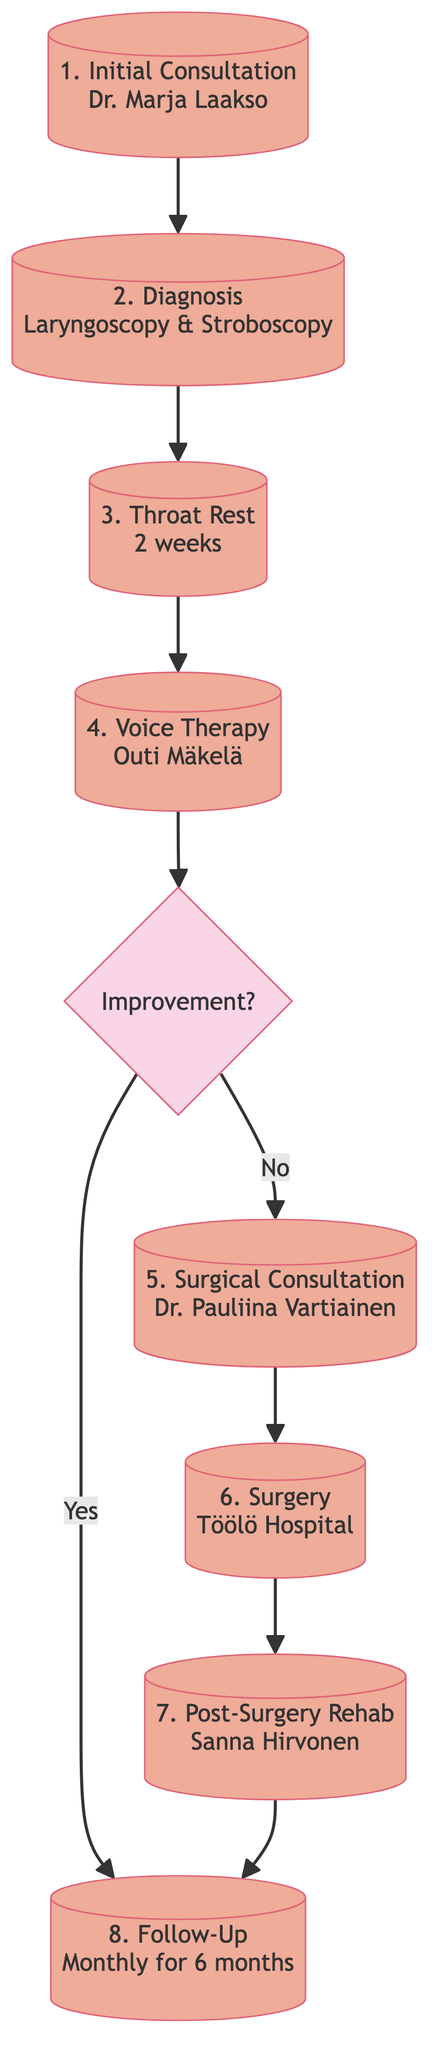What is the first step in the patient journey? The diagram indicates that the first step is the "Initial Consultation," where the patient consults a reputable otolaryngologist such as Dr. Marja Laakso.
Answer: Initial Consultation How many steps are there in the patient journey? By counting the nodes in the diagram, we find that there are a total of eight steps that describe the patient journey from initial consultation to follow-up.
Answer: 8 What happens after the throat rest if there is no improvement? If there is no improvement after the throat rest, the next step is the "Surgical Consultation" with Dr. Pauliina Vartiainen.
Answer: Surgical Consultation Who provides the voice therapy after surgery? The diagram shows that the voice therapy after surgery is provided by Sanna Hirvonen at Sanni's Music Academy.
Answer: Sanna Hirvonen What is the duration of the throat rest recommended? The patient is advised to have a throat rest for a duration of 2 weeks as indicated in the diagram.
Answer: 2 weeks What type of instrument is used for diagnosis? The diagram specifies that the diagnosis is performed using the "Philips NL9 Stroboscopy System" during laryngoscopy and stroboscopy.
Answer: Philips NL9 Stroboscopy System What is the purpose of the follow-up after treatment? The follow-up serves the purpose of monitoring the patient's recovery, indicated in the diagram as monthly check-ups for six months.
Answer: Monitor recovery What step comes after non-surgical treatment if improvement is not observed? If there is no improvement after non-surgical treatment, the next step is the "Surgical Consultation."
Answer: Surgical Consultation 